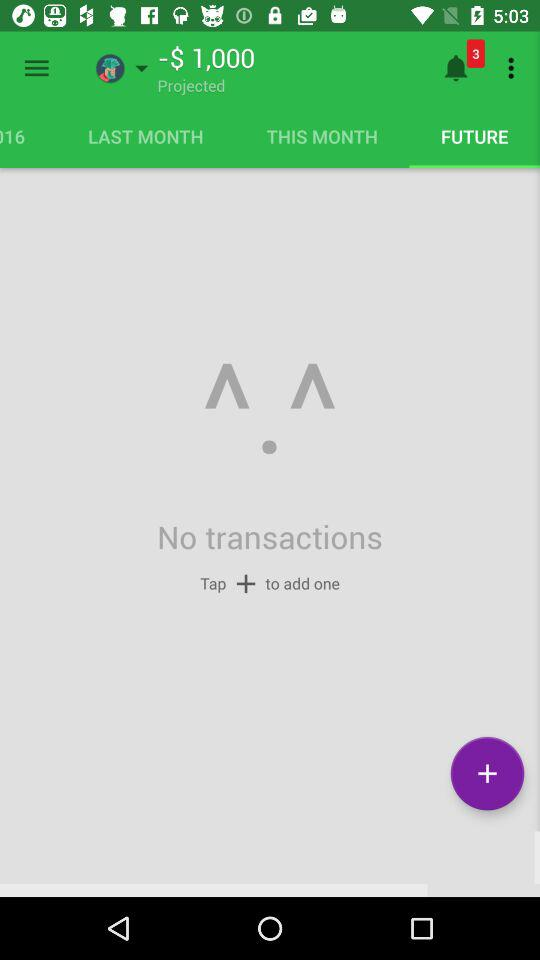How many transactions are there?
Answer the question using a single word or phrase. 0 